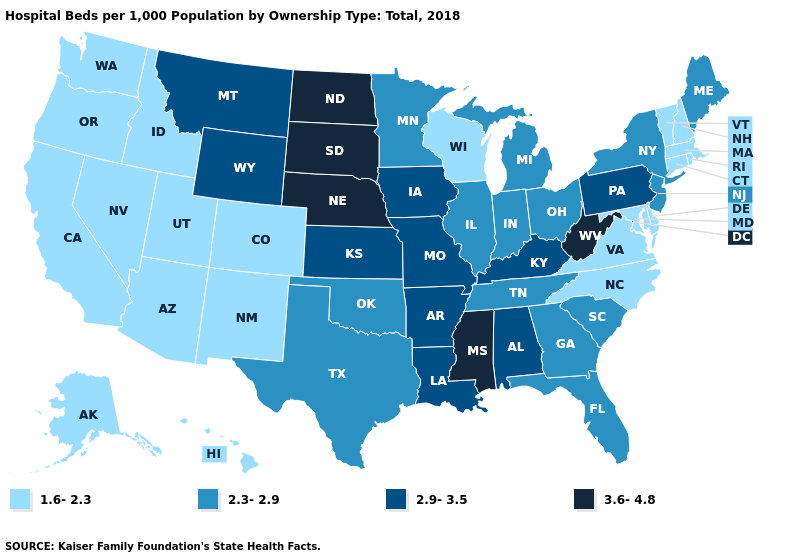Which states have the highest value in the USA?
Answer briefly. Mississippi, Nebraska, North Dakota, South Dakota, West Virginia. Does Tennessee have the same value as Connecticut?
Concise answer only. No. What is the lowest value in states that border Delaware?
Write a very short answer. 1.6-2.3. Which states hav the highest value in the MidWest?
Answer briefly. Nebraska, North Dakota, South Dakota. What is the highest value in the USA?
Give a very brief answer. 3.6-4.8. Name the states that have a value in the range 3.6-4.8?
Write a very short answer. Mississippi, Nebraska, North Dakota, South Dakota, West Virginia. Among the states that border Colorado , does Nebraska have the highest value?
Write a very short answer. Yes. Does Nebraska have the highest value in the USA?
Answer briefly. Yes. Does the first symbol in the legend represent the smallest category?
Be succinct. Yes. Which states have the lowest value in the USA?
Short answer required. Alaska, Arizona, California, Colorado, Connecticut, Delaware, Hawaii, Idaho, Maryland, Massachusetts, Nevada, New Hampshire, New Mexico, North Carolina, Oregon, Rhode Island, Utah, Vermont, Virginia, Washington, Wisconsin. What is the lowest value in states that border Texas?
Give a very brief answer. 1.6-2.3. What is the value of Iowa?
Keep it brief. 2.9-3.5. Does the map have missing data?
Short answer required. No. Among the states that border Vermont , does New Hampshire have the lowest value?
Be succinct. Yes. Does Massachusetts have the lowest value in the USA?
Short answer required. Yes. 